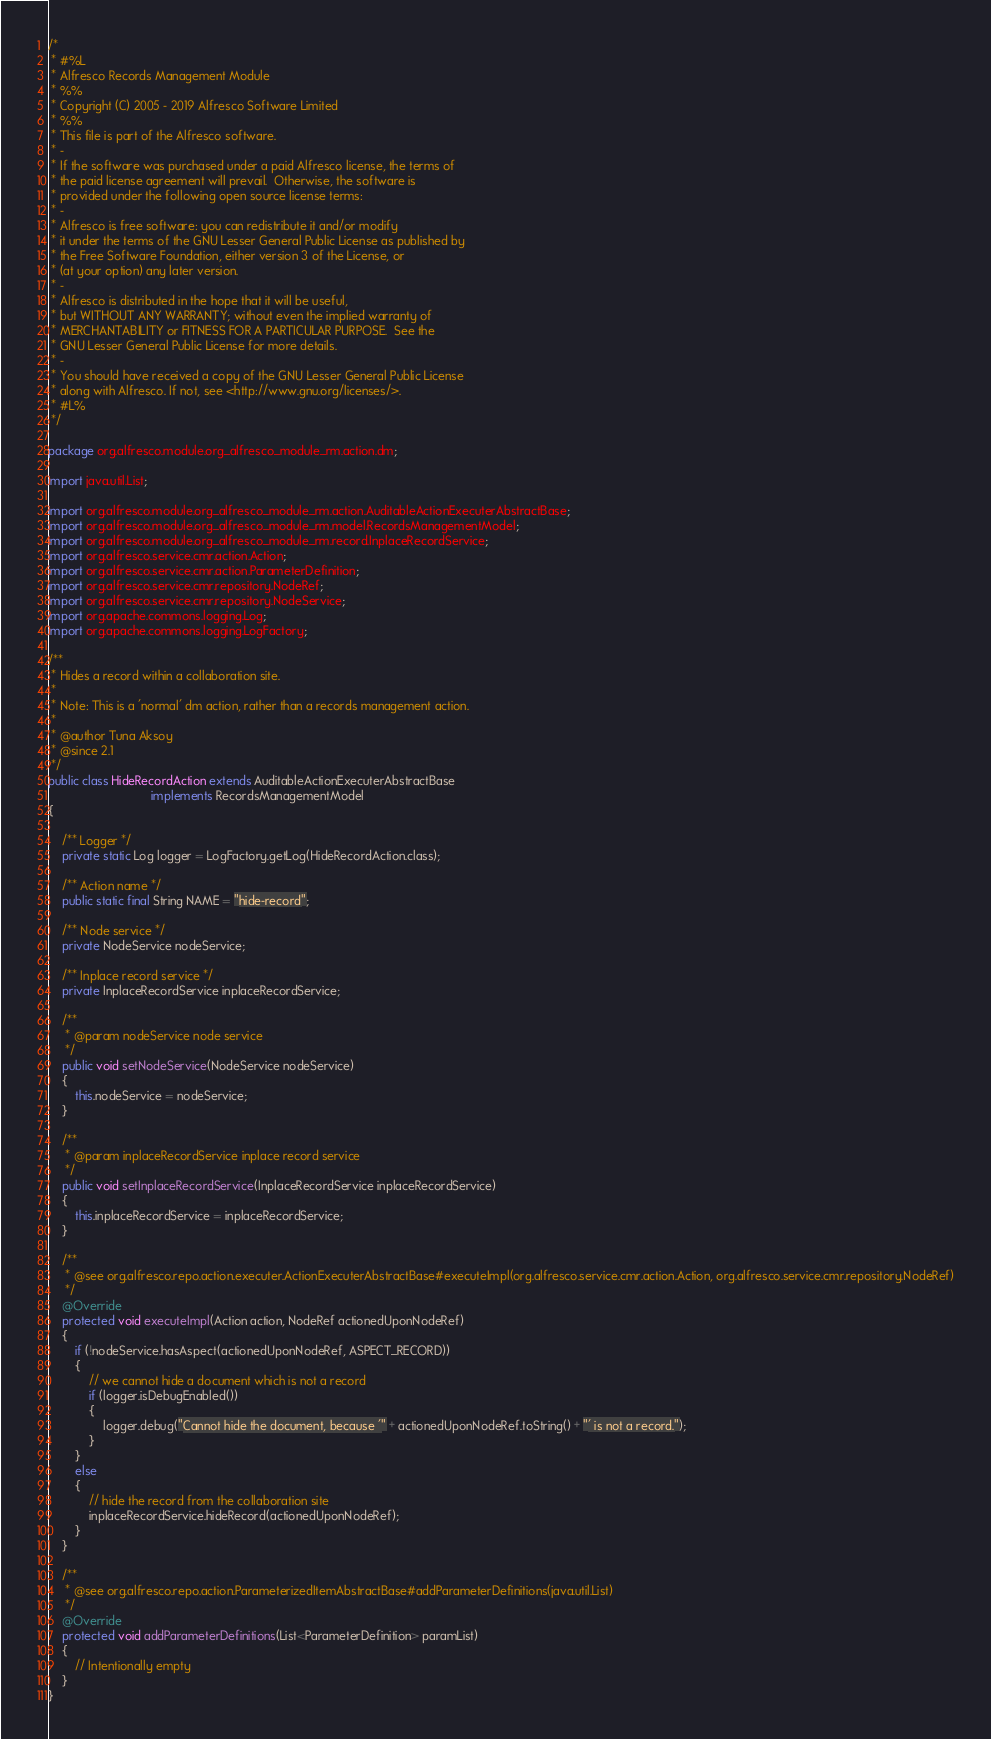Convert code to text. <code><loc_0><loc_0><loc_500><loc_500><_Java_>/*
 * #%L
 * Alfresco Records Management Module
 * %%
 * Copyright (C) 2005 - 2019 Alfresco Software Limited
 * %%
 * This file is part of the Alfresco software.
 * -
 * If the software was purchased under a paid Alfresco license, the terms of
 * the paid license agreement will prevail.  Otherwise, the software is
 * provided under the following open source license terms:
 * -
 * Alfresco is free software: you can redistribute it and/or modify
 * it under the terms of the GNU Lesser General Public License as published by
 * the Free Software Foundation, either version 3 of the License, or
 * (at your option) any later version.
 * -
 * Alfresco is distributed in the hope that it will be useful,
 * but WITHOUT ANY WARRANTY; without even the implied warranty of
 * MERCHANTABILITY or FITNESS FOR A PARTICULAR PURPOSE.  See the
 * GNU Lesser General Public License for more details.
 * -
 * You should have received a copy of the GNU Lesser General Public License
 * along with Alfresco. If not, see <http://www.gnu.org/licenses/>.
 * #L%
 */

package org.alfresco.module.org_alfresco_module_rm.action.dm;

import java.util.List;

import org.alfresco.module.org_alfresco_module_rm.action.AuditableActionExecuterAbstractBase;
import org.alfresco.module.org_alfresco_module_rm.model.RecordsManagementModel;
import org.alfresco.module.org_alfresco_module_rm.record.InplaceRecordService;
import org.alfresco.service.cmr.action.Action;
import org.alfresco.service.cmr.action.ParameterDefinition;
import org.alfresco.service.cmr.repository.NodeRef;
import org.alfresco.service.cmr.repository.NodeService;
import org.apache.commons.logging.Log;
import org.apache.commons.logging.LogFactory;

/**
 * Hides a record within a collaboration site.
 *
 * Note: This is a 'normal' dm action, rather than a records management action.
 *
 * @author Tuna Aksoy
 * @since 2.1
 */
public class HideRecordAction extends AuditableActionExecuterAbstractBase
                              implements RecordsManagementModel
{

    /** Logger */
    private static Log logger = LogFactory.getLog(HideRecordAction.class);

    /** Action name */
    public static final String NAME = "hide-record";

    /** Node service */
    private NodeService nodeService;

    /** Inplace record service */
    private InplaceRecordService inplaceRecordService;

    /**
     * @param nodeService node service
     */
    public void setNodeService(NodeService nodeService)
    {
        this.nodeService = nodeService;
    }

    /**
     * @param inplaceRecordService inplace record service
     */
    public void setInplaceRecordService(InplaceRecordService inplaceRecordService)
    {
        this.inplaceRecordService = inplaceRecordService;
    }

    /**
     * @see org.alfresco.repo.action.executer.ActionExecuterAbstractBase#executeImpl(org.alfresco.service.cmr.action.Action, org.alfresco.service.cmr.repository.NodeRef)
     */
    @Override
    protected void executeImpl(Action action, NodeRef actionedUponNodeRef)
    {
        if (!nodeService.hasAspect(actionedUponNodeRef, ASPECT_RECORD))
        {
            // we cannot hide a document which is not a record
            if (logger.isDebugEnabled())
            {
                logger.debug("Cannot hide the document, because '" + actionedUponNodeRef.toString() + "' is not a record.");
            }
        }
        else
        {
            // hide the record from the collaboration site
            inplaceRecordService.hideRecord(actionedUponNodeRef);
        }
    }

    /**
     * @see org.alfresco.repo.action.ParameterizedItemAbstractBase#addParameterDefinitions(java.util.List)
     */
    @Override
    protected void addParameterDefinitions(List<ParameterDefinition> paramList)
    {
        // Intentionally empty
    }
}
</code> 